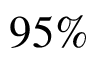<formula> <loc_0><loc_0><loc_500><loc_500>9 5 \%</formula> 